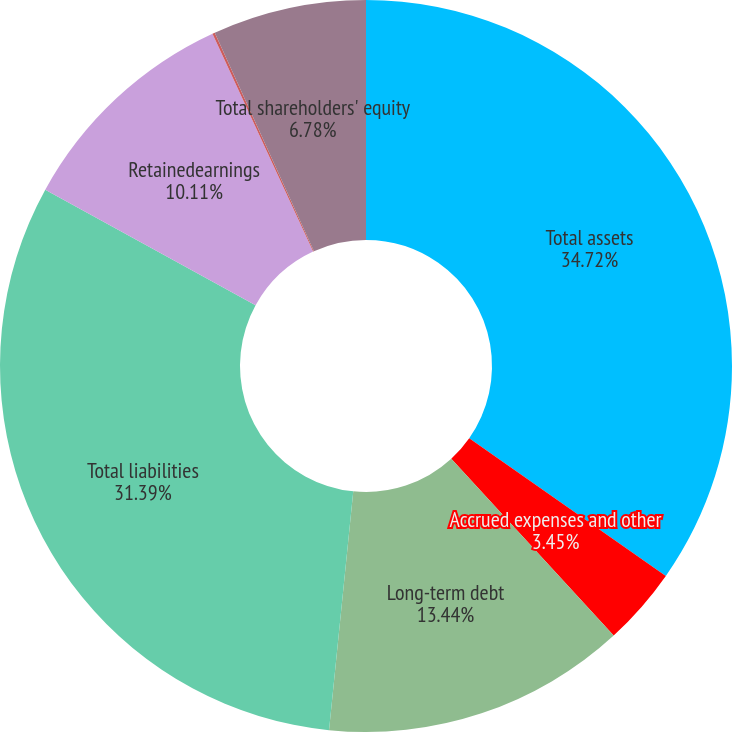<chart> <loc_0><loc_0><loc_500><loc_500><pie_chart><fcel>Total assets<fcel>Accrued expenses and other<fcel>Long-term debt<fcel>Total liabilities<fcel>Retainedearnings<fcel>Accumulated other<fcel>Total shareholders' equity<nl><fcel>34.72%<fcel>3.45%<fcel>13.44%<fcel>31.39%<fcel>10.11%<fcel>0.11%<fcel>6.78%<nl></chart> 